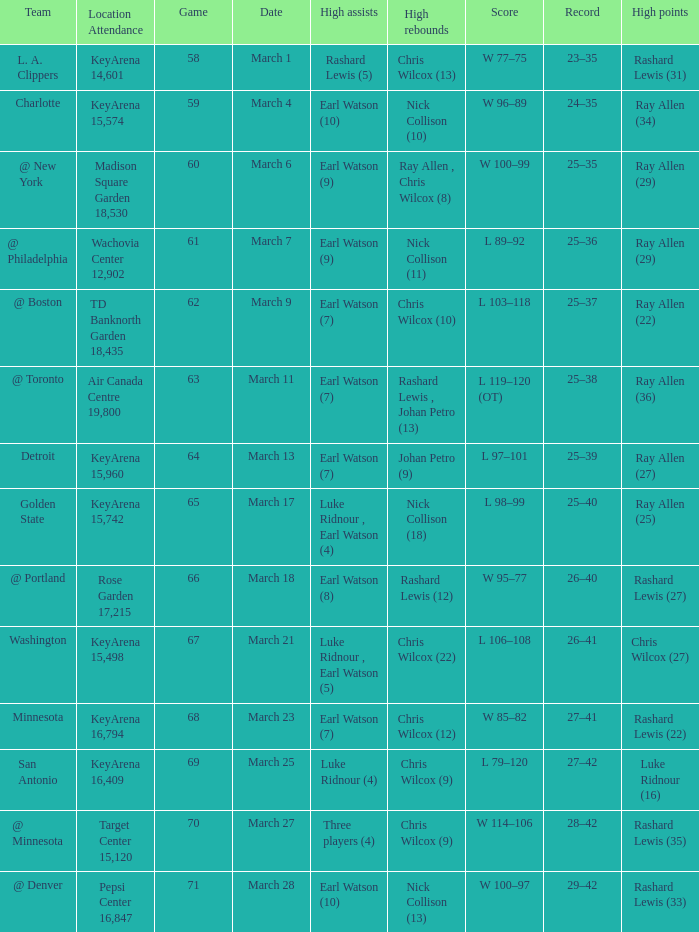Who had the most points in the game on March 7? Ray Allen (29). 